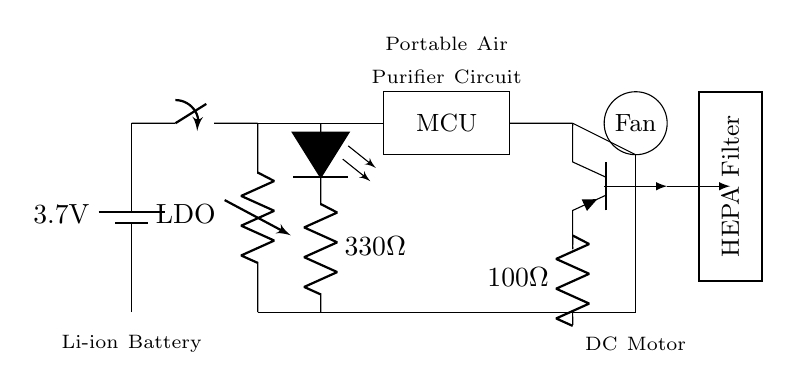What is the voltage of the battery? The battery in the circuit is labeled as 3.7 volts, indicating that this is the voltage supplied to the circuit.
Answer: 3.7 volts What component is used to regulate voltage? The diagram shows an LDO (Low Dropout Regulator) connected to the power switch, which indicates that this component is responsible for regulating the voltage coming from the battery to the necessary levels for the circuit.
Answer: LDO What type of switch is shown in the circuit? The circuit includes a power switch, depicted in a standard switch symbol, that is used to control the flow of power from the battery to the rest of the circuit.
Answer: Power switch What is the function of the HEPA filter? The HEPA filter is symbolically represented in the circuit to indicate its role in purifying the air processed by the fan, thereby filtering out particulate matter and contaminants.
Answer: Air purification How does the fan receive power in this circuit? The circuit diagram shows the fan is connected in series with a transistor (Tpnp) which is controlled by the microcontroller. When the microcontroller activates the transistor, it allows current to flow from the voltage regulator to the fan, effectively powering it.
Answer: Through the transistor What is the resistance value of the resistor connected to the fan? The circuit indicates there is a 100 Ohm resistor connected in series with the fan circuit, which can be used to limit the current flowing through the fan to protect it.
Answer: 100 Ohm What is the purpose of the LED in this circuit? The LED is connected in parallel with a resistor and is an indicator light that shows whether the circuit is powered on. When current flows through, the LED will light up, signaling that the air purifier is operational.
Answer: Power indicator 